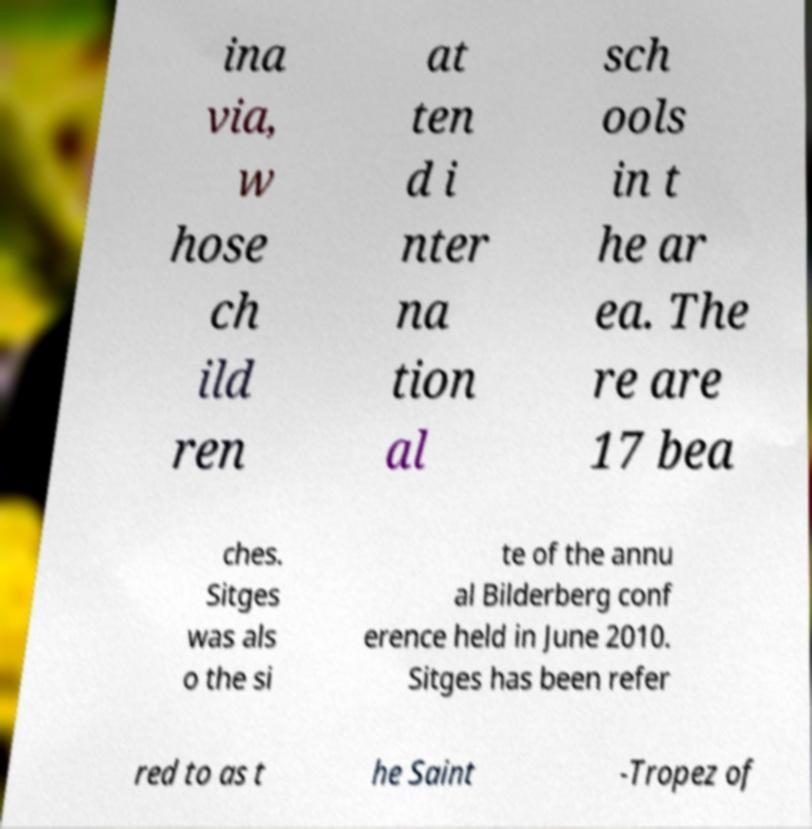Can you read and provide the text displayed in the image?This photo seems to have some interesting text. Can you extract and type it out for me? ina via, w hose ch ild ren at ten d i nter na tion al sch ools in t he ar ea. The re are 17 bea ches. Sitges was als o the si te of the annu al Bilderberg conf erence held in June 2010. Sitges has been refer red to as t he Saint -Tropez of 